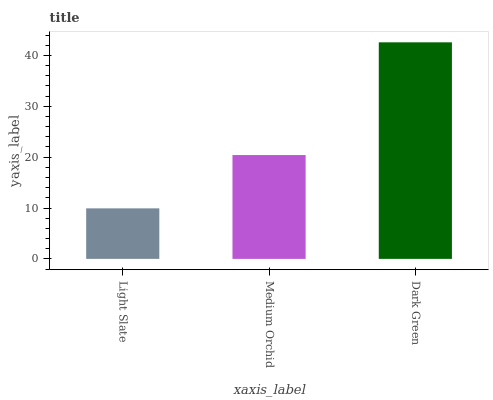Is Light Slate the minimum?
Answer yes or no. Yes. Is Dark Green the maximum?
Answer yes or no. Yes. Is Medium Orchid the minimum?
Answer yes or no. No. Is Medium Orchid the maximum?
Answer yes or no. No. Is Medium Orchid greater than Light Slate?
Answer yes or no. Yes. Is Light Slate less than Medium Orchid?
Answer yes or no. Yes. Is Light Slate greater than Medium Orchid?
Answer yes or no. No. Is Medium Orchid less than Light Slate?
Answer yes or no. No. Is Medium Orchid the high median?
Answer yes or no. Yes. Is Medium Orchid the low median?
Answer yes or no. Yes. Is Light Slate the high median?
Answer yes or no. No. Is Light Slate the low median?
Answer yes or no. No. 